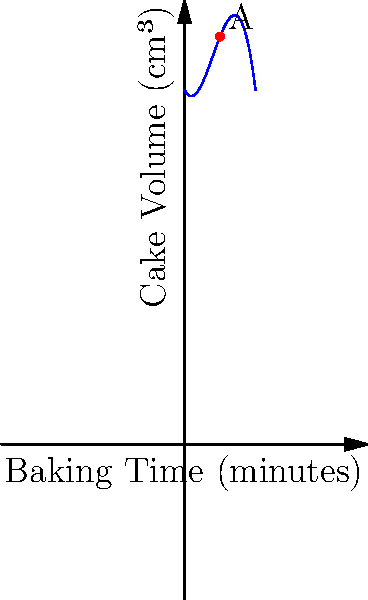As a novice baker eager to learn, you're experimenting with cake recipes. The graph shows the relationship between baking time and cake volume using a cubic polynomial function. Point A represents the optimal baking time and volume. What is the approximate optimal baking time (x-coordinate of point A) for achieving the maximum cake volume? To find the optimal baking time, we need to identify the x-coordinate of the highest point on the curve (point A). Let's break this down step-by-step:

1. The graph represents a cubic function of the form $f(x) = ax^3 + bx^2 + cx + d$, where $x$ is the baking time and $f(x)$ is the cake volume.

2. The maximum point of a cubic function occurs at the peak of the curve, where the slope (derivative) is zero.

3. By visual inspection, we can see that the peak of the curve (point A) is located approximately halfway between 0 and 10 on the x-axis.

4. The x-axis is labeled "Baking Time (minutes)", and the scale appears to be in increments of 1 minute.

5. Counting the grid lines from 0, we can estimate that point A is located at approximately the 5th grid line.

Therefore, the optimal baking time, represented by the x-coordinate of point A, is approximately 5 minutes.

This simplified model suggests that baking the cake for about 5 minutes would yield the maximum volume. However, in real-world baking, times are typically longer, and various factors affect the optimal baking time.
Answer: 5 minutes 